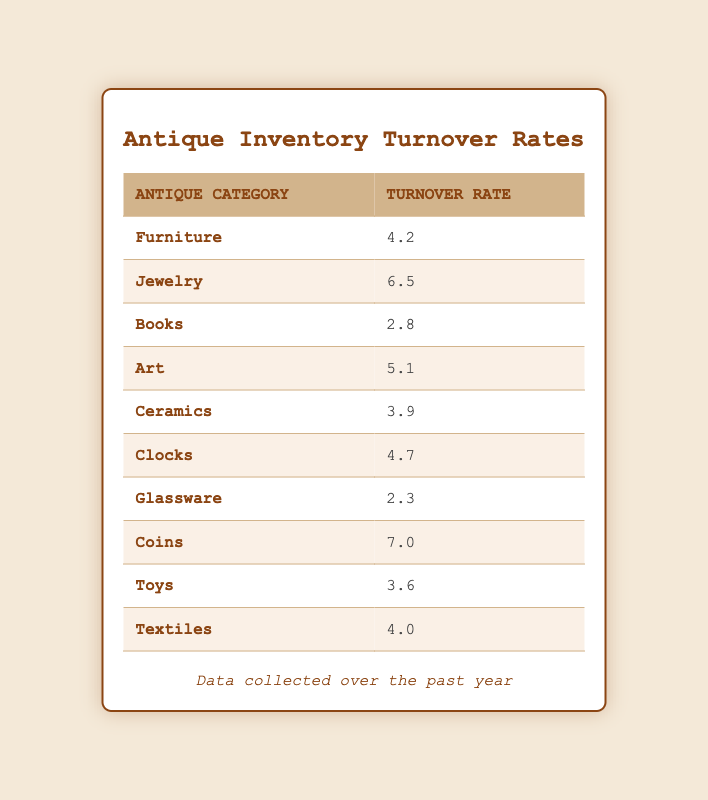What is the turnover rate for the Jewelry category? The turnover rate for the Jewelry category is listed directly in the table under the corresponding row.
Answer: 6.5 Which antique category has the highest turnover rate? The highest turnover rate is found by comparing all turnover rates in the table. The Coins category has a turnover rate of 7.0, which is the highest among all categories.
Answer: Coins What is the average turnover rate of all antique categories? To find the average, add all turnover rates: (4.2 + 6.5 + 2.8 + 5.1 + 3.9 + 4.7 + 2.3 + 7.0 + 3.6 + 4.0) = 44.1. Then, divide by the number of categories, which is 10. So, the average is 44.1/10 = 4.41.
Answer: 4.41 Is the turnover rate for Art greater than that for Ceramics? The turnover rate for Art is 5.1 and for Ceramics is 3.9. Since 5.1 is greater than 3.9, the answer is yes.
Answer: Yes What is the total turnover rate of Furniture, Clocks, and Textiles combined? To find the total, add the turnover rates of these three categories: Furniture (4.2) + Clocks (4.7) + Textiles (4.0) = 4.2 + 4.7 + 4.0 = 12.9.
Answer: 12.9 How many antique categories have a turnover rate below 4.0? By inspecting the turnover rates in the table, the categories below 4.0 are Books (2.8), Glassware (2.3), and Toys (3.6). Thus, there are three categories with rates below 4.0.
Answer: 3 What is the difference between the highest and lowest turnover rates? The highest turnover rate is from Coins (7.0) and the lowest is from Glassware (2.3). To find the difference: 7.0 - 2.3 = 4.7.
Answer: 4.7 Which categories have a turnover rate of 4.0 or higher? The categories with a rate of 4.0 or higher are Furniture (4.2), Jewelry (6.5), Art (5.1), Clocks (4.7), Coins (7.0), and Textiles (4.0). Counting these, there are six categories.
Answer: 6 Is it true that all antique categories have a turnover rate above 2.0? Checking each category: the lowest is Glassware at 2.3, above 2.0. Therefore, all categories have turnover rates above 2.0, making the statement true.
Answer: Yes 